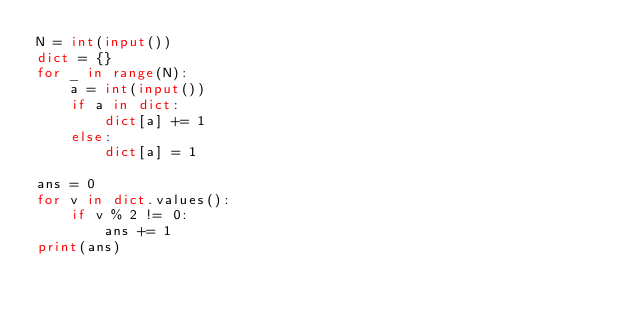<code> <loc_0><loc_0><loc_500><loc_500><_Python_>N = int(input())
dict = {}
for _ in range(N):
    a = int(input())
    if a in dict:
        dict[a] += 1
    else:
        dict[a] = 1

ans = 0
for v in dict.values():
    if v % 2 != 0:
        ans += 1
print(ans)</code> 